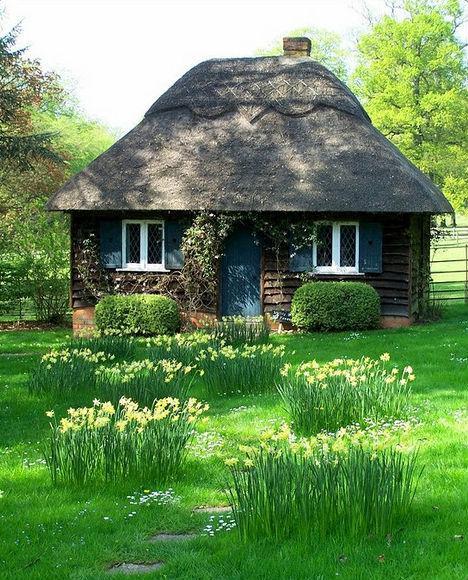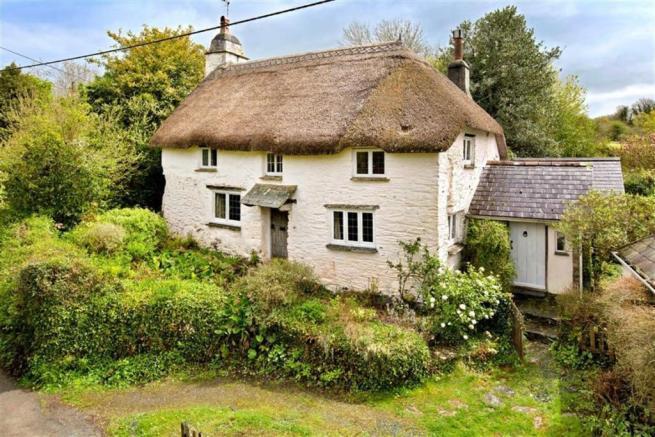The first image is the image on the left, the second image is the image on the right. Analyze the images presented: Is the assertion "On the left a green lawn rises up to meet a white country cottage." valid? Answer yes or no. No. 